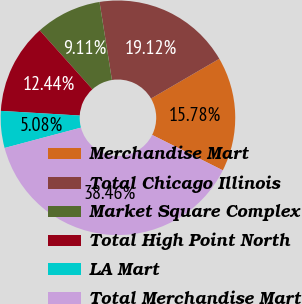Convert chart to OTSL. <chart><loc_0><loc_0><loc_500><loc_500><pie_chart><fcel>Merchandise Mart<fcel>Total Chicago Illinois<fcel>Market Square Complex<fcel>Total High Point North<fcel>LA Mart<fcel>Total Merchandise Mart<nl><fcel>15.78%<fcel>19.12%<fcel>9.11%<fcel>12.44%<fcel>5.08%<fcel>38.46%<nl></chart> 